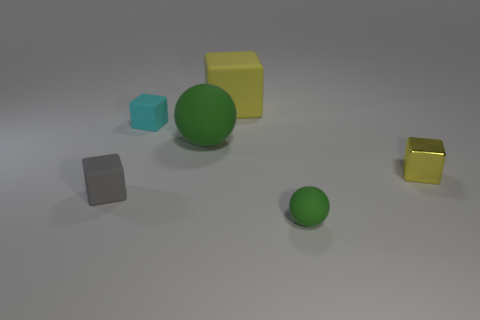Is there a big rubber cube of the same color as the metal object?
Provide a succinct answer. Yes. There is a big thing that is the same color as the small ball; what material is it?
Offer a very short reply. Rubber. How many big matte blocks have the same color as the tiny rubber ball?
Keep it short and to the point. 0. How many objects are either matte things that are right of the cyan rubber block or large yellow matte blocks?
Offer a very short reply. 3. What color is the large ball that is made of the same material as the cyan block?
Make the answer very short. Green. Is there a blue object of the same size as the gray matte block?
Offer a very short reply. No. What number of things are spheres behind the small gray object or small cyan blocks in front of the large yellow matte thing?
Offer a very short reply. 2. The gray matte thing that is the same size as the cyan object is what shape?
Offer a terse response. Cube. Is there a small yellow metallic thing of the same shape as the tiny cyan object?
Your response must be concise. Yes. Is the number of small brown matte blocks less than the number of small gray matte cubes?
Your answer should be compact. Yes. 